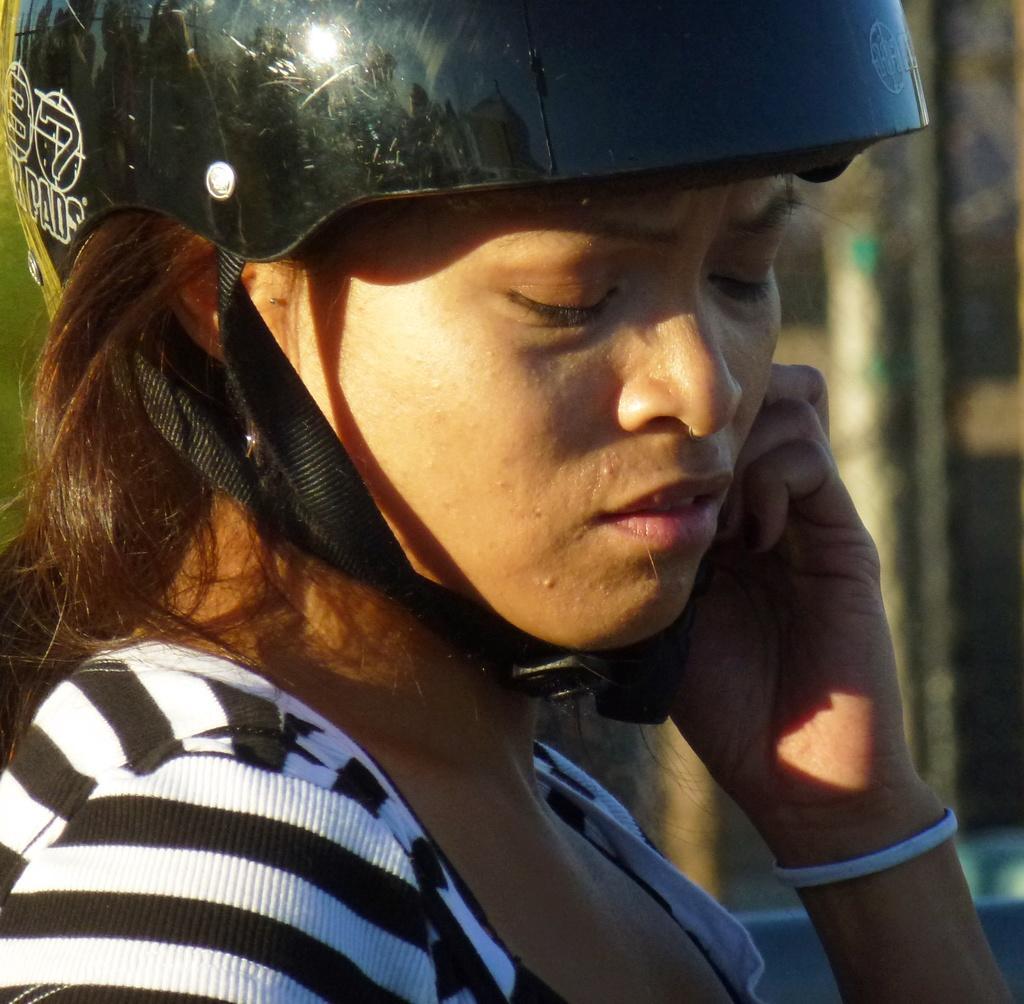Please provide a concise description of this image. In this picture we can see a woman, she wore a helmet and we can see blurry background. 